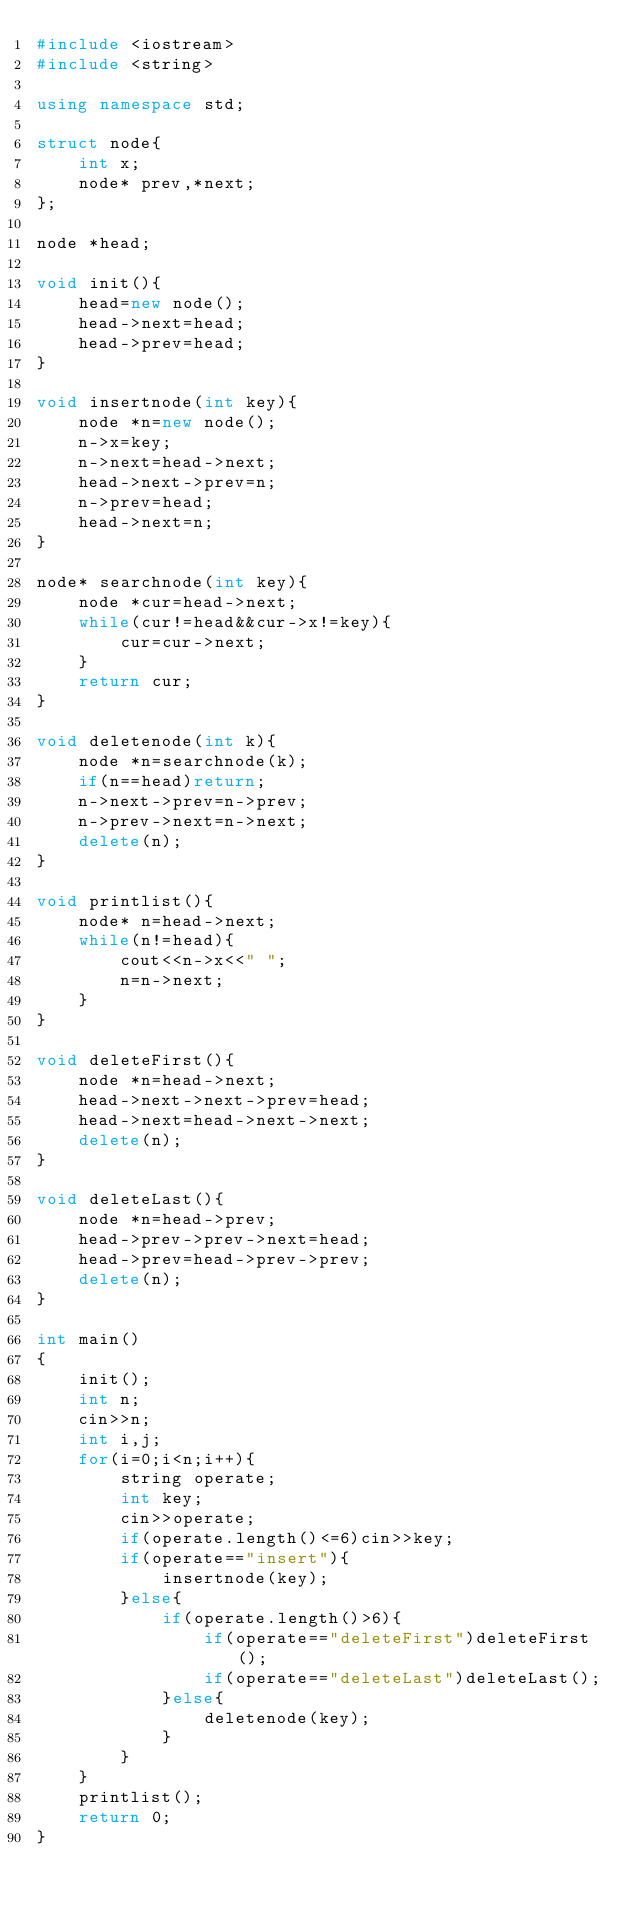Convert code to text. <code><loc_0><loc_0><loc_500><loc_500><_C++_>#include <iostream>
#include <string>

using namespace std;

struct node{
    int x;
    node* prev,*next;
};

node *head;

void init(){
    head=new node();
    head->next=head;
    head->prev=head;
}

void insertnode(int key){
    node *n=new node();
    n->x=key;
    n->next=head->next;
    head->next->prev=n;
    n->prev=head;
    head->next=n;
}

node* searchnode(int key){
    node *cur=head->next;
    while(cur!=head&&cur->x!=key){
        cur=cur->next;
    }
    return cur;
}

void deletenode(int k){
    node *n=searchnode(k);
    if(n==head)return;
    n->next->prev=n->prev;
    n->prev->next=n->next;
    delete(n);
}

void printlist(){
    node* n=head->next;
    while(n!=head){
        cout<<n->x<<" ";
        n=n->next;
    }
}

void deleteFirst(){
    node *n=head->next;
    head->next->next->prev=head;
    head->next=head->next->next;
    delete(n);
}

void deleteLast(){
    node *n=head->prev;
    head->prev->prev->next=head;
    head->prev=head->prev->prev;
    delete(n);
}

int main()
{
    init();
    int n;
    cin>>n;
    int i,j;
    for(i=0;i<n;i++){
        string operate;
        int key;
        cin>>operate;
        if(operate.length()<=6)cin>>key;
        if(operate=="insert"){
            insertnode(key);
        }else{
            if(operate.length()>6){
                if(operate=="deleteFirst")deleteFirst();
                if(operate=="deleteLast")deleteLast();
            }else{
                deletenode(key);
            }
        }
    }
    printlist();
    return 0;
}</code> 